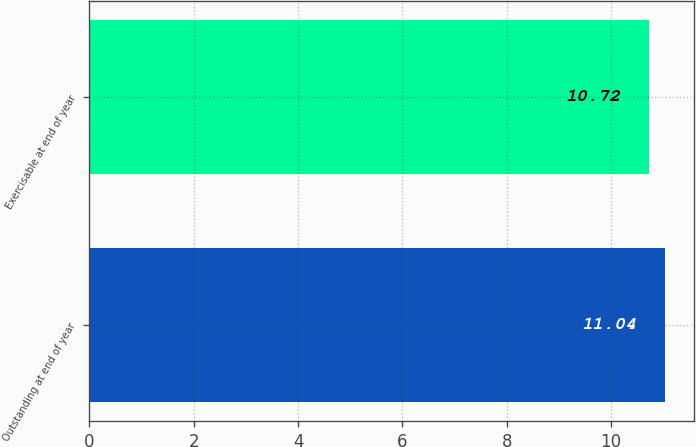<chart> <loc_0><loc_0><loc_500><loc_500><bar_chart><fcel>Outstanding at end of year<fcel>Exercisable at end of year<nl><fcel>11.04<fcel>10.72<nl></chart> 